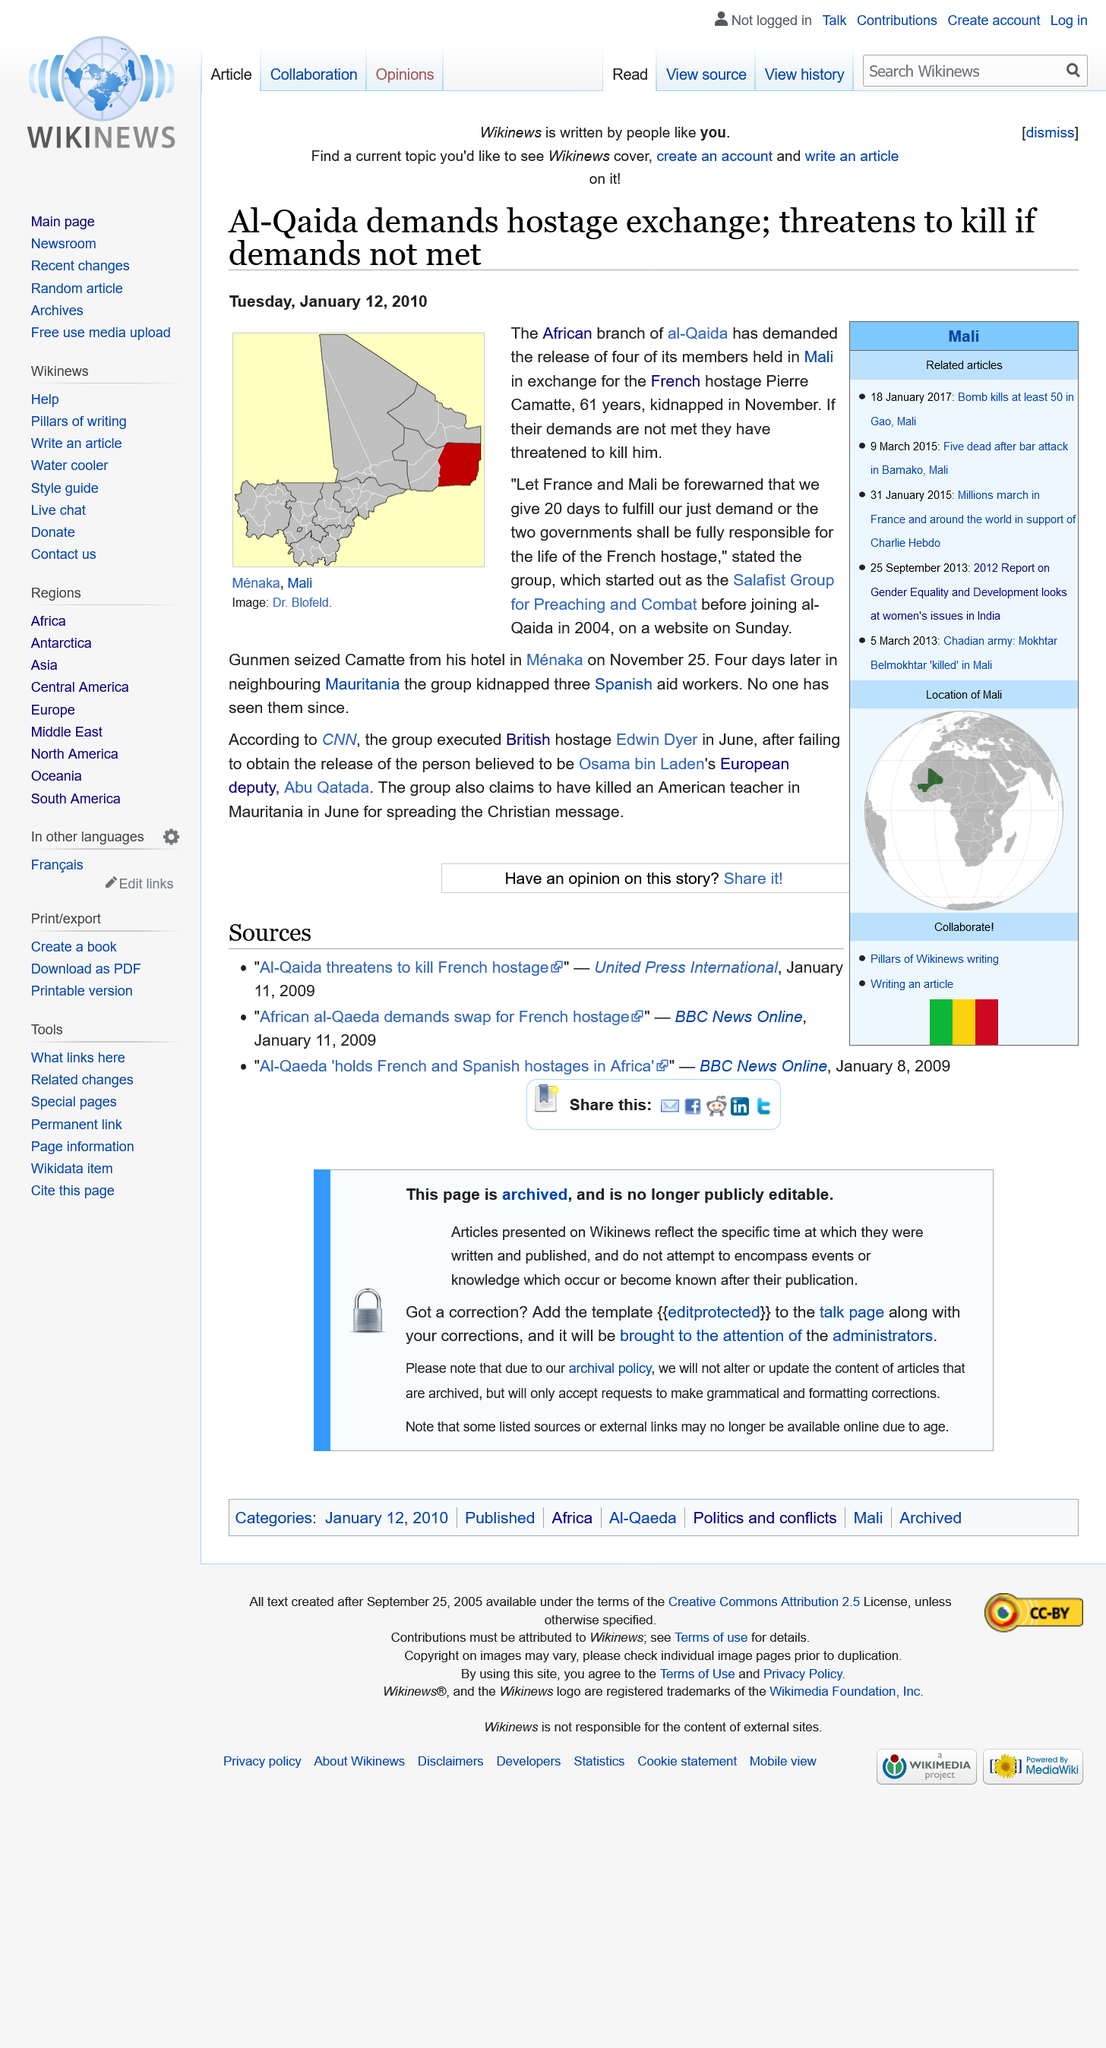Highlight a few significant elements in this photo. On November 25th, the hostage was captured. The hostage is 61 years old. A French citizen named Pierre Camatte has been kidnapped, and the kidnappers have given France and Mali 20 days to make a decision regarding the hostage's release. 